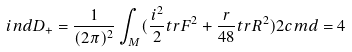<formula> <loc_0><loc_0><loc_500><loc_500>i n d D _ { + } = \frac { 1 } { ( 2 \pi ) ^ { 2 } } \int _ { M } ( \frac { i ^ { 2 } } { 2 } t r F ^ { 2 } + \frac { r } { 4 8 } t r R ^ { 2 } ) 2 c m d = 4</formula> 